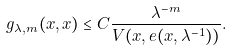Convert formula to latex. <formula><loc_0><loc_0><loc_500><loc_500>g _ { \lambda , m } ( x , x ) \leq C \frac { \lambda ^ { - m } } { V ( x , e ( x , \lambda ^ { - 1 } ) ) } .</formula> 